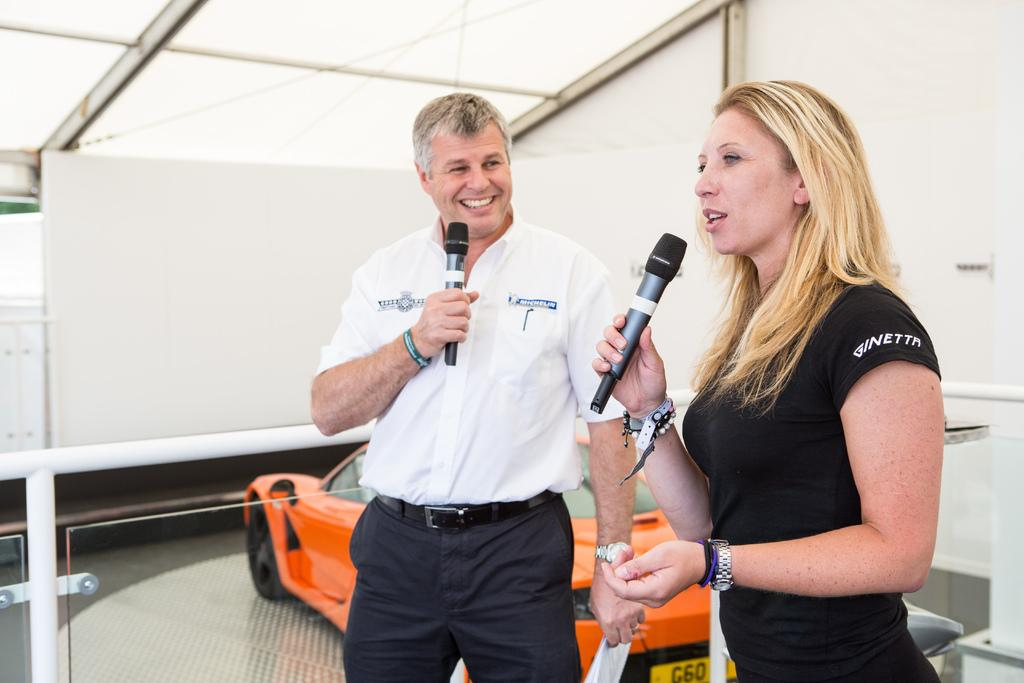How many people are in the image? There are two persons standing in the image. What are the persons holding in their hands? The persons are holding microphones. What can be seen in the background of the image? There is a wall and a car in the background of the image. Can you tell me how deep the quicksand is in the image? There is no quicksand present in the image. What is the relationship between the two persons in the image? The provided facts do not mention the relationship between the two persons. 